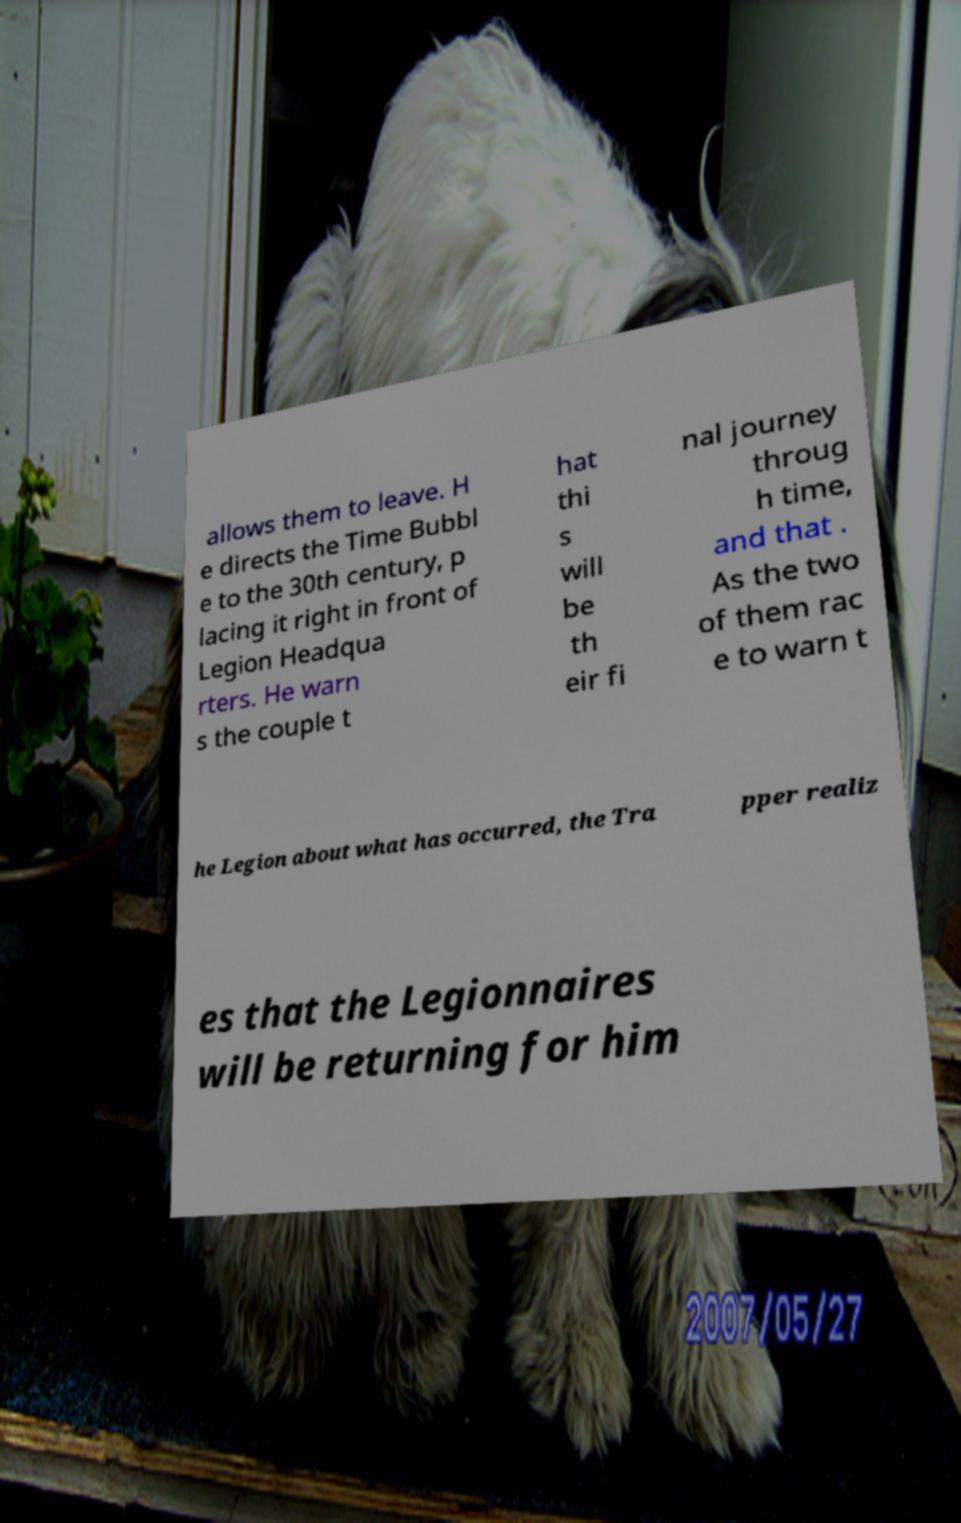For documentation purposes, I need the text within this image transcribed. Could you provide that? allows them to leave. H e directs the Time Bubbl e to the 30th century, p lacing it right in front of Legion Headqua rters. He warn s the couple t hat thi s will be th eir fi nal journey throug h time, and that . As the two of them rac e to warn t he Legion about what has occurred, the Tra pper realiz es that the Legionnaires will be returning for him 